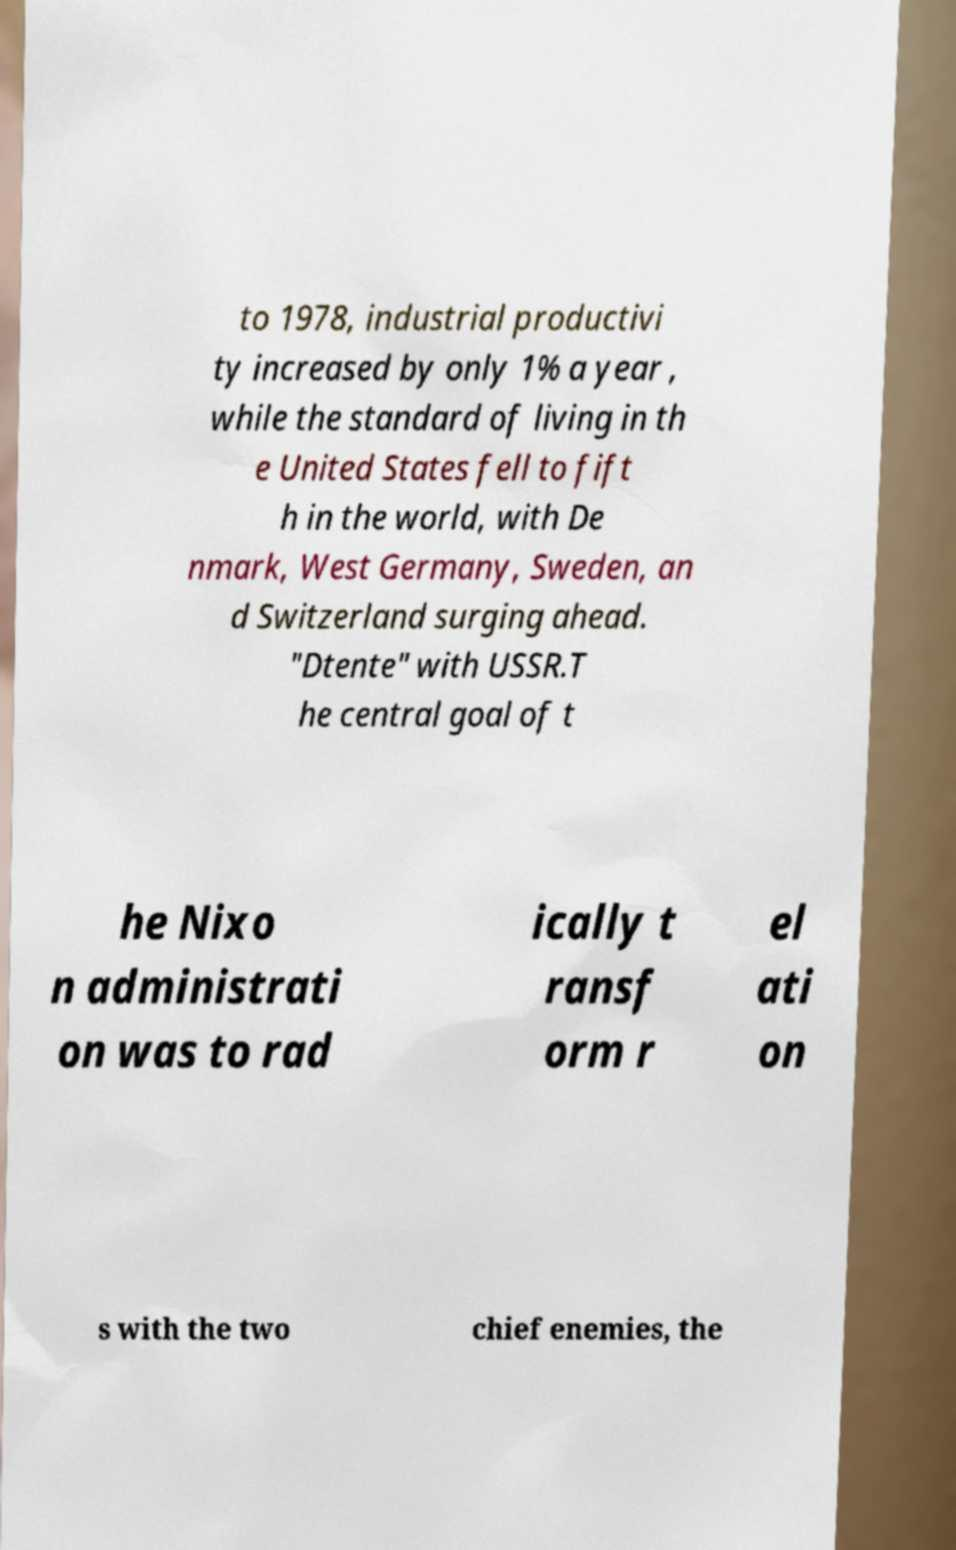Could you assist in decoding the text presented in this image and type it out clearly? to 1978, industrial productivi ty increased by only 1% a year , while the standard of living in th e United States fell to fift h in the world, with De nmark, West Germany, Sweden, an d Switzerland surging ahead. "Dtente" with USSR.T he central goal of t he Nixo n administrati on was to rad ically t ransf orm r el ati on s with the two chief enemies, the 